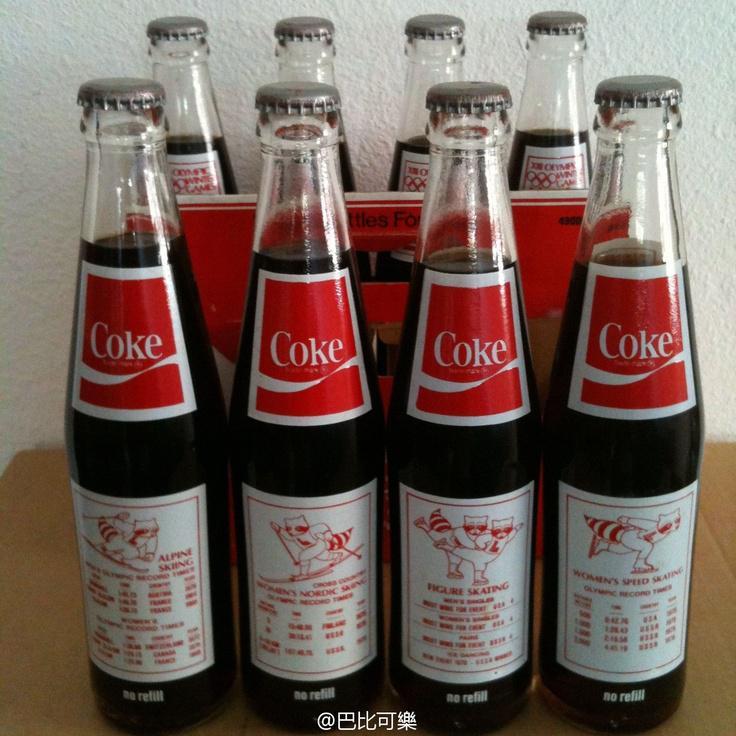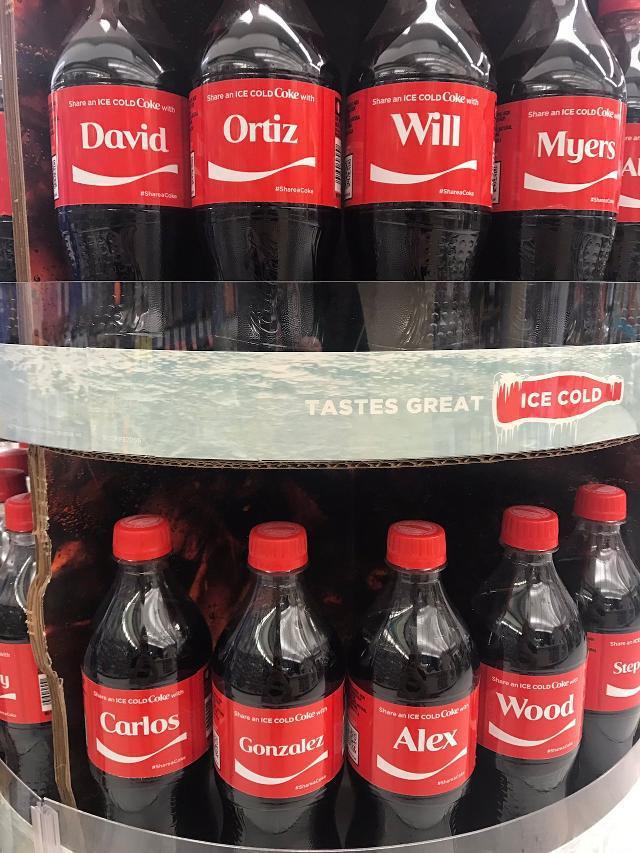The first image is the image on the left, the second image is the image on the right. Evaluate the accuracy of this statement regarding the images: "There are at most four bottles of soda in one of the images.". Is it true? Answer yes or no. No. 